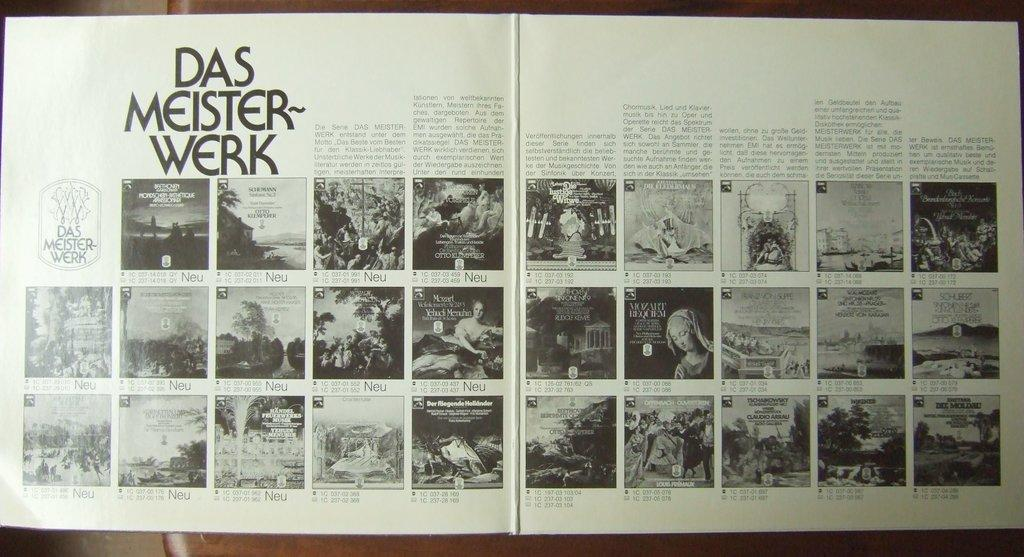<image>
Create a compact narrative representing the image presented. Das Meister- Werk open book with Neu imprinted at the bottom. 